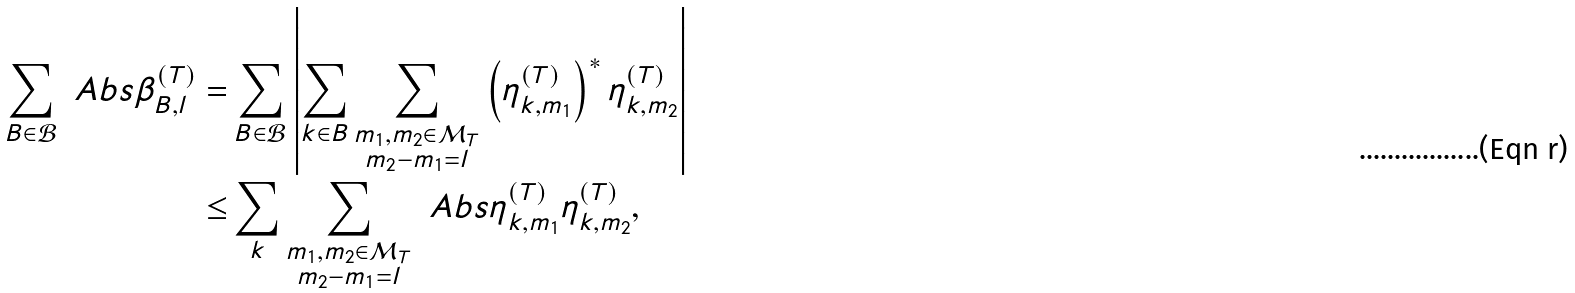Convert formula to latex. <formula><loc_0><loc_0><loc_500><loc_500>\sum _ { B \in \mathcal { B } } \ A b s { \beta ^ { ( T ) } _ { B , l } } = & \sum _ { B \in \mathcal { B } } \left | \sum _ { k \in B } \sum _ { \substack { m _ { 1 } , m _ { 2 } \in \mathcal { M } _ { T } \\ m _ { 2 } - m _ { 1 } = l } } \left ( \eta ^ { ( T ) } _ { k , m _ { 1 } } \right ) ^ { \ast } \eta ^ { ( T ) } _ { k , m _ { 2 } } \right | \\ \leq & \sum _ { k } \sum _ { \substack { m _ { 1 } , m _ { 2 } \in \mathcal { M } _ { T } \\ m _ { 2 } - m _ { 1 } = l } } \ A b s { \eta ^ { ( T ) } _ { k , m _ { 1 } } \eta ^ { ( T ) } _ { k , m _ { 2 } } } ,</formula> 